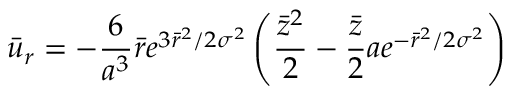<formula> <loc_0><loc_0><loc_500><loc_500>{ \bar { u } } _ { r } = - \frac { 6 } { a ^ { 3 } } \bar { r } e ^ { 3 \bar { r } ^ { 2 } / 2 { \sigma } ^ { 2 } } \left ( \frac { \bar { z } ^ { 2 } } { 2 } - \frac { \bar { z } } { 2 } a e ^ { - \bar { r } ^ { 2 } / 2 { \sigma } ^ { 2 } } \right )</formula> 